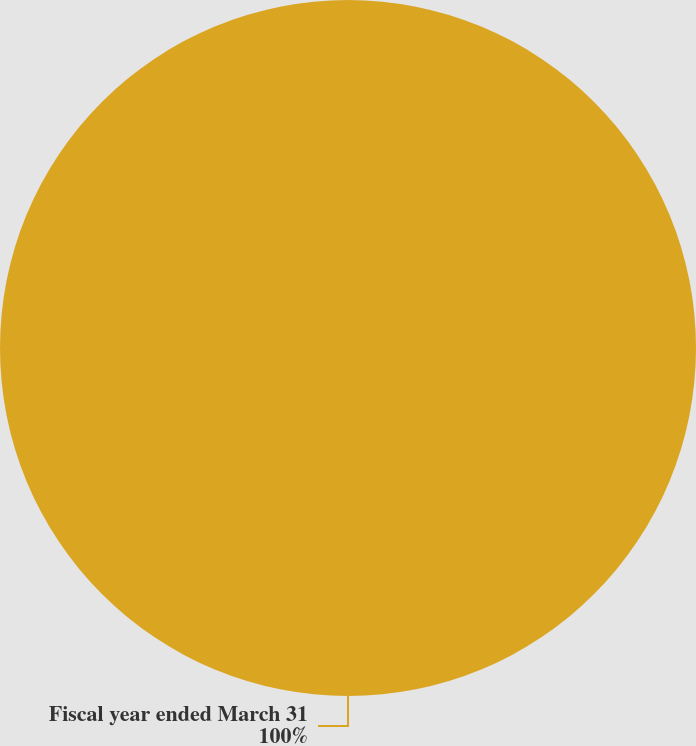<chart> <loc_0><loc_0><loc_500><loc_500><pie_chart><fcel>Fiscal year ended March 31<nl><fcel>100.0%<nl></chart> 